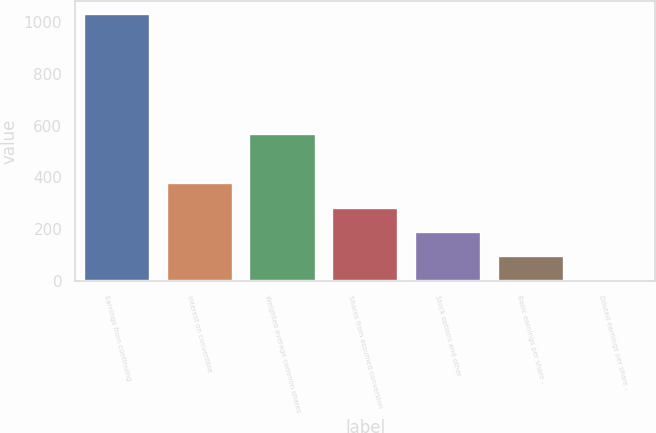Convert chart. <chart><loc_0><loc_0><loc_500><loc_500><bar_chart><fcel>Earnings from continuing<fcel>Interest on convertible<fcel>Weighted average common shares<fcel>Shares from assumed conversion<fcel>Stock options and other<fcel>Basic earnings per share -<fcel>Diluted earnings per share -<nl><fcel>1027.82<fcel>378.07<fcel>565.71<fcel>284.25<fcel>190.43<fcel>96.61<fcel>2.79<nl></chart> 